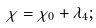Convert formula to latex. <formula><loc_0><loc_0><loc_500><loc_500>\chi = \chi _ { 0 } + \lambda _ { 4 } ;</formula> 